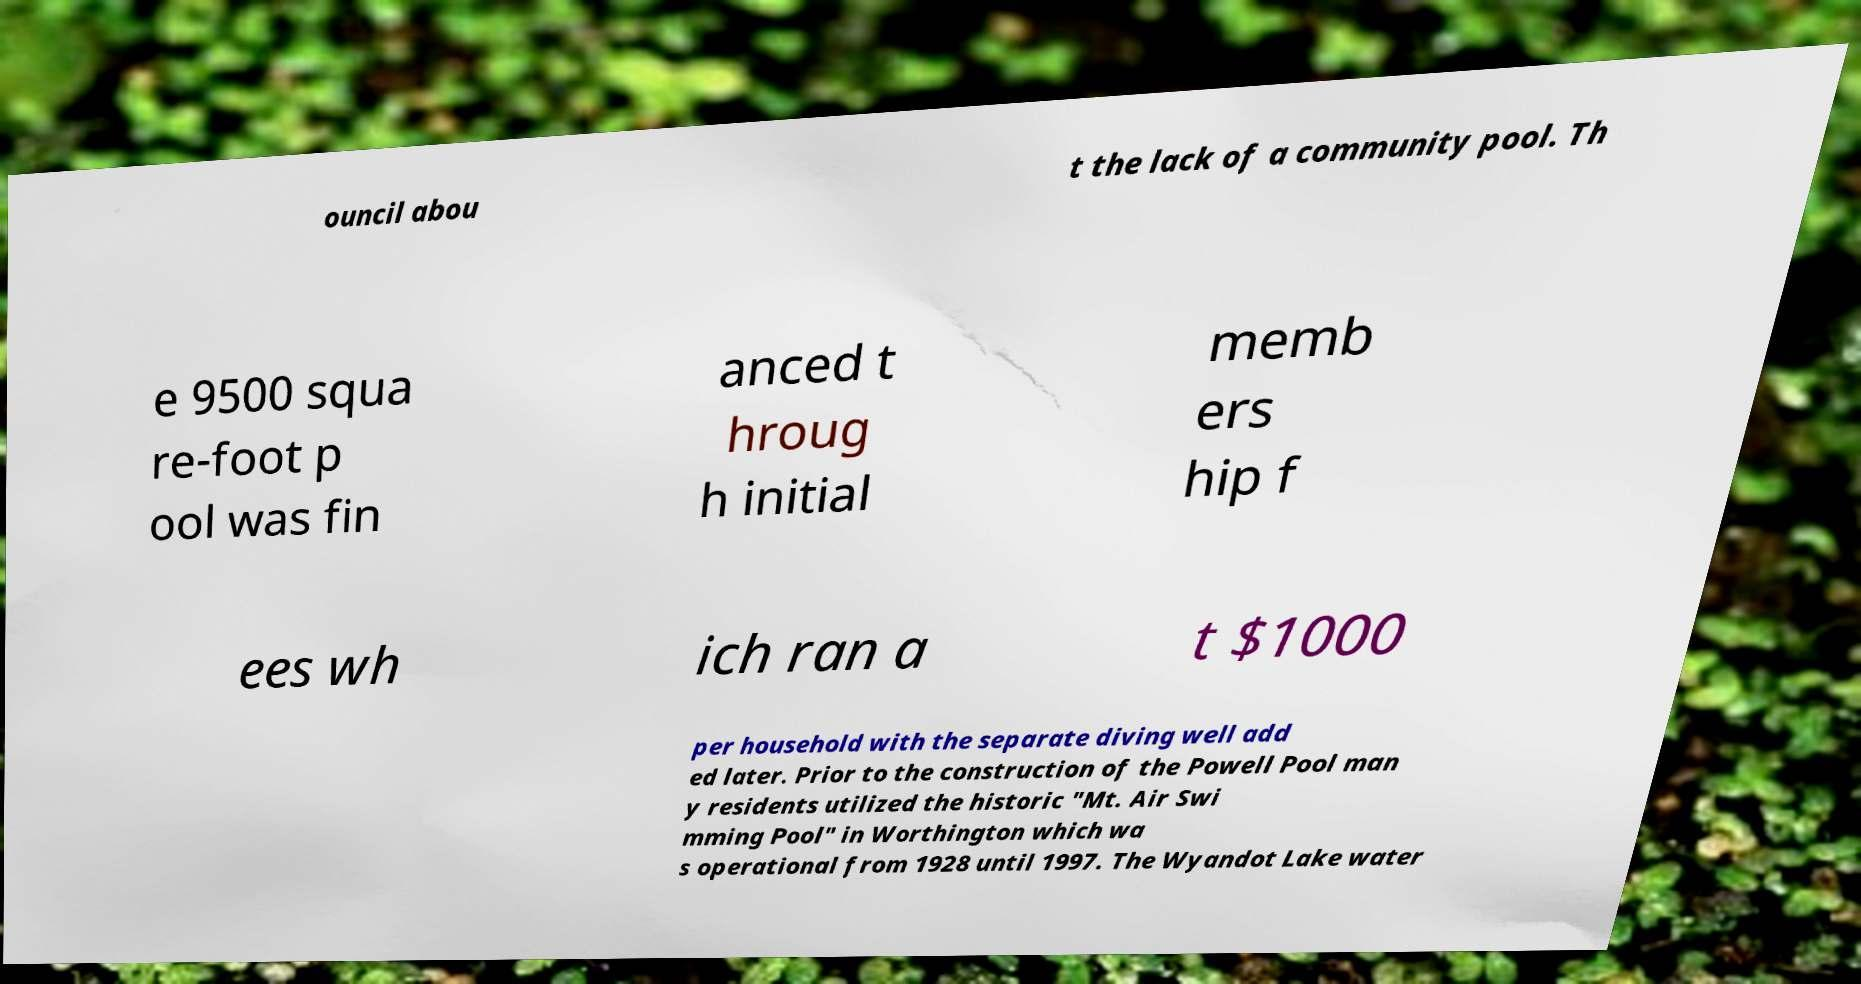Can you accurately transcribe the text from the provided image for me? ouncil abou t the lack of a community pool. Th e 9500 squa re-foot p ool was fin anced t hroug h initial memb ers hip f ees wh ich ran a t $1000 per household with the separate diving well add ed later. Prior to the construction of the Powell Pool man y residents utilized the historic "Mt. Air Swi mming Pool" in Worthington which wa s operational from 1928 until 1997. The Wyandot Lake water 